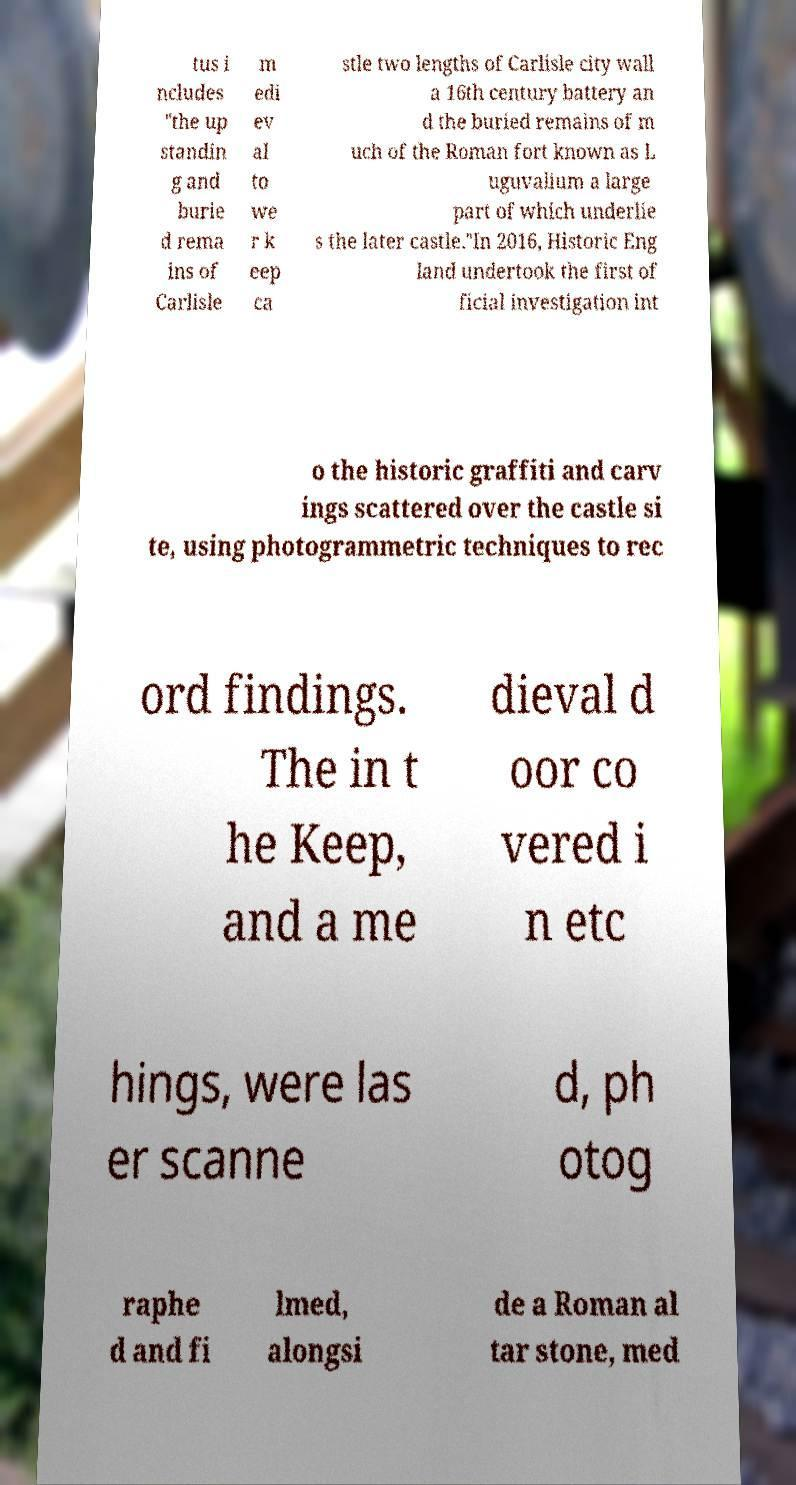There's text embedded in this image that I need extracted. Can you transcribe it verbatim? tus i ncludes "the up standin g and burie d rema ins of Carlisle m edi ev al to we r k eep ca stle two lengths of Carlisle city wall a 16th century battery an d the buried remains of m uch of the Roman fort known as L uguvalium a large part of which underlie s the later castle."In 2016, Historic Eng land undertook the first of ficial investigation int o the historic graffiti and carv ings scattered over the castle si te, using photogrammetric techniques to rec ord findings. The in t he Keep, and a me dieval d oor co vered i n etc hings, were las er scanne d, ph otog raphe d and fi lmed, alongsi de a Roman al tar stone, med 